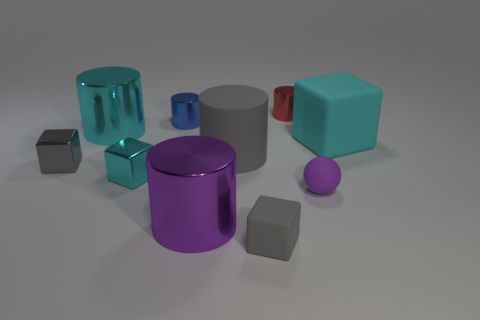Subtract all blue cylinders. How many cylinders are left? 4 Subtract 1 cylinders. How many cylinders are left? 4 Subtract all red cylinders. How many cylinders are left? 4 Subtract all brown cylinders. Subtract all purple blocks. How many cylinders are left? 5 Subtract all spheres. How many objects are left? 9 Add 4 big cyan cylinders. How many big cyan cylinders are left? 5 Add 5 green shiny things. How many green shiny things exist? 5 Subtract 0 purple cubes. How many objects are left? 10 Subtract all small gray rubber things. Subtract all tiny gray objects. How many objects are left? 7 